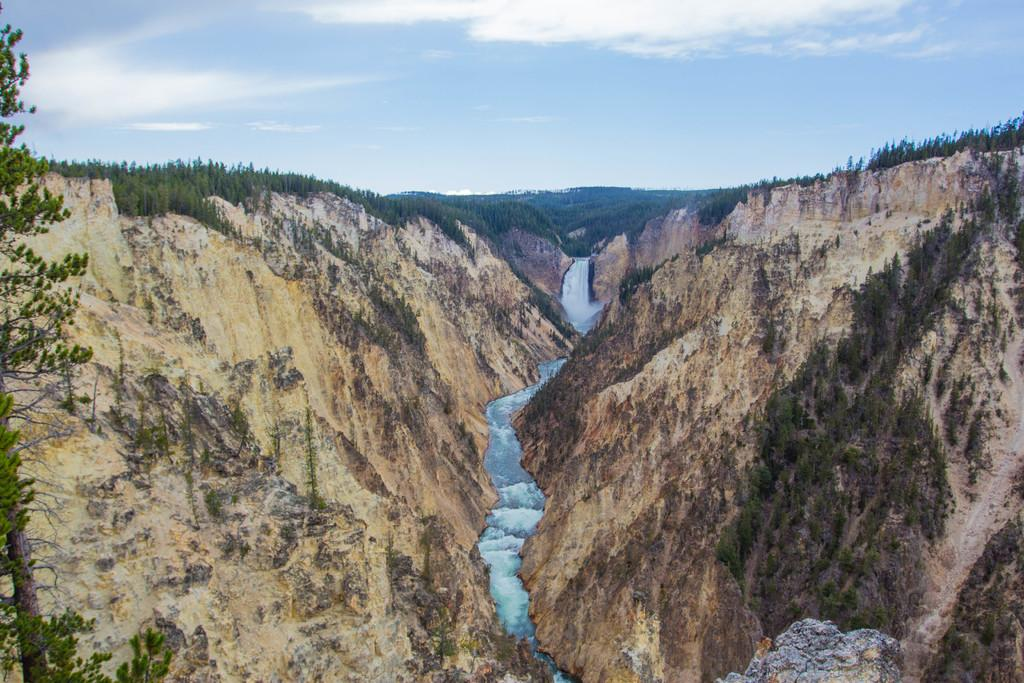What is the main feature in the center of the image? There is water in the center of the image. What can be seen on the sides of the water? There are rocks on both the right and left sides of the image. What type of vegetation is visible in the background of the image? There are trees in the background of the image. What is visible above the trees in the image? The sky is visible in the background of the image. Where is the nest of cherries located in the image? There is no nest or cherries present in the image. What is being rubbed on the rocks in the image? There is no rubbing or any indication of rubbing in the image. 